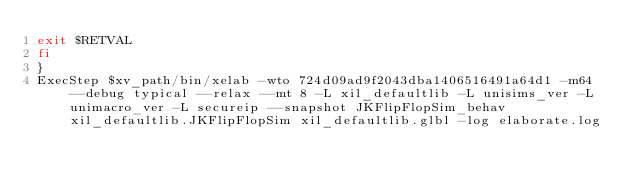<code> <loc_0><loc_0><loc_500><loc_500><_Bash_>exit $RETVAL
fi
}
ExecStep $xv_path/bin/xelab -wto 724d09ad9f2043dba1406516491a64d1 -m64 --debug typical --relax --mt 8 -L xil_defaultlib -L unisims_ver -L unimacro_ver -L secureip --snapshot JKFlipFlopSim_behav xil_defaultlib.JKFlipFlopSim xil_defaultlib.glbl -log elaborate.log
</code> 